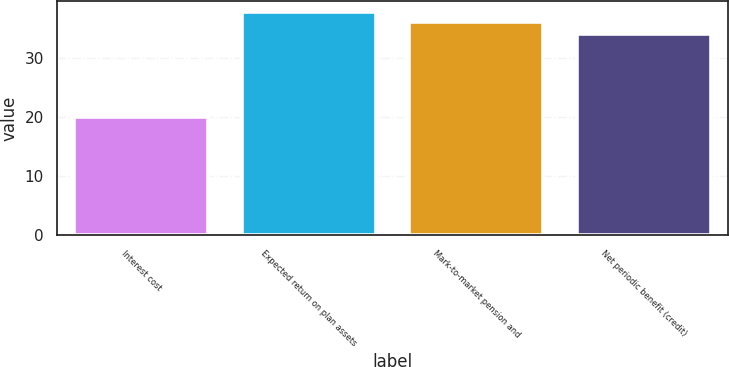Convert chart to OTSL. <chart><loc_0><loc_0><loc_500><loc_500><bar_chart><fcel>Interest cost<fcel>Expected return on plan assets<fcel>Mark-to-market pension and<fcel>Net periodic benefit (credit)<nl><fcel>20<fcel>37.7<fcel>36<fcel>34<nl></chart> 